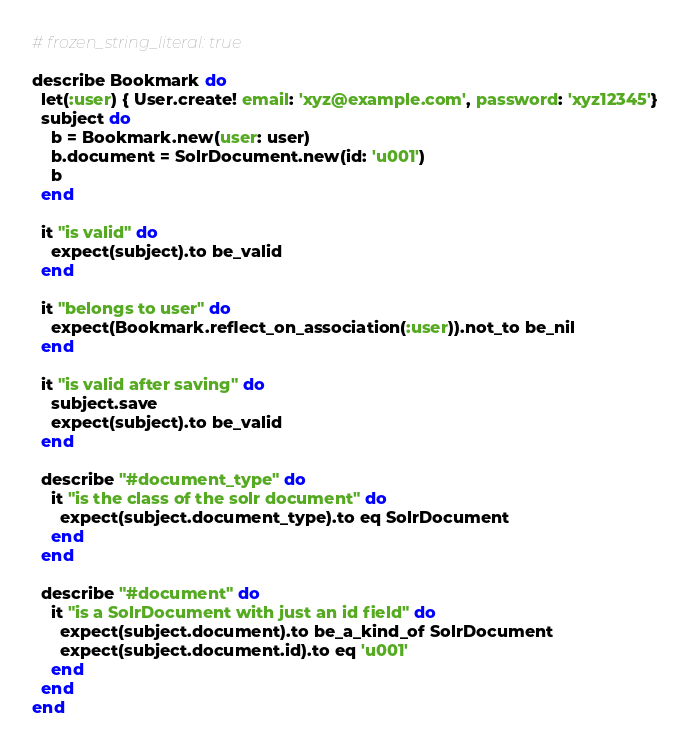<code> <loc_0><loc_0><loc_500><loc_500><_Ruby_># frozen_string_literal: true

describe Bookmark do
  let(:user) { User.create! email: 'xyz@example.com', password: 'xyz12345'}
  subject do
    b = Bookmark.new(user: user)
    b.document = SolrDocument.new(id: 'u001')
    b
  end

  it "is valid" do
    expect(subject).to be_valid
  end

  it "belongs to user" do
    expect(Bookmark.reflect_on_association(:user)).not_to be_nil
  end

  it "is valid after saving" do
    subject.save
    expect(subject).to be_valid
  end
  
  describe "#document_type" do
    it "is the class of the solr document" do
      expect(subject.document_type).to eq SolrDocument
    end
  end
  
  describe "#document" do
    it "is a SolrDocument with just an id field" do
      expect(subject.document).to be_a_kind_of SolrDocument
      expect(subject.document.id).to eq 'u001'
    end
  end
end
</code> 